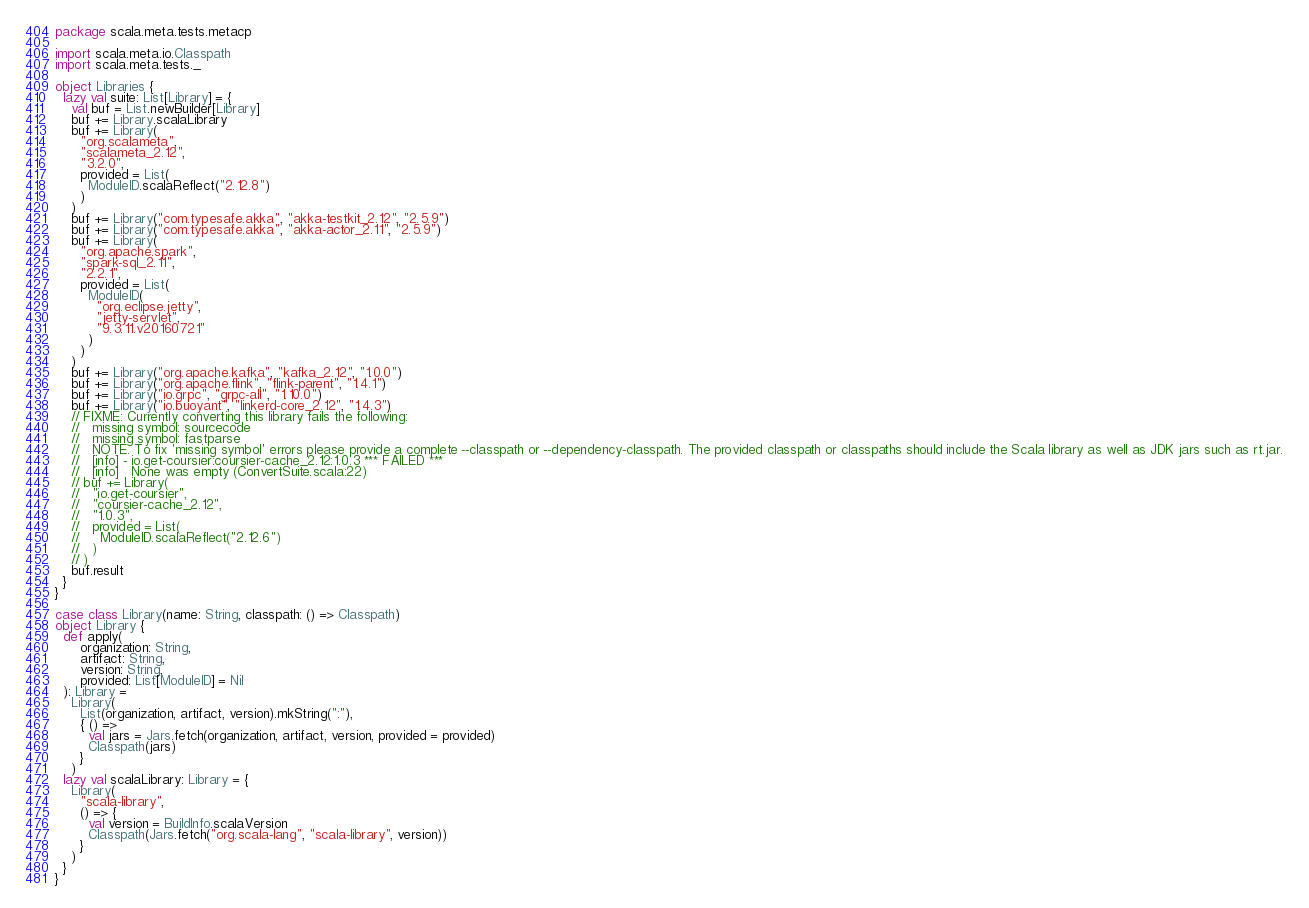<code> <loc_0><loc_0><loc_500><loc_500><_Scala_>package scala.meta.tests.metacp

import scala.meta.io.Classpath
import scala.meta.tests._

object Libraries {
  lazy val suite: List[Library] = {
    val buf = List.newBuilder[Library]
    buf += Library.scalaLibrary
    buf += Library(
      "org.scalameta",
      "scalameta_2.12",
      "3.2.0",
      provided = List(
        ModuleID.scalaReflect("2.12.8")
      )
    )
    buf += Library("com.typesafe.akka", "akka-testkit_2.12", "2.5.9")
    buf += Library("com.typesafe.akka", "akka-actor_2.11", "2.5.9")
    buf += Library(
      "org.apache.spark",
      "spark-sql_2.11",
      "2.2.1",
      provided = List(
        ModuleID(
          "org.eclipse.jetty",
          "jetty-servlet",
          "9.3.11.v20160721"
        )
      )
    )
    buf += Library("org.apache.kafka", "kafka_2.12", "1.0.0")
    buf += Library("org.apache.flink", "flink-parent", "1.4.1")
    buf += Library("io.grpc", "grpc-all", "1.10.0")
    buf += Library("io.buoyant", "linkerd-core_2.12", "1.4.3")
    // FIXME: Currently converting this library fails the following:
    //   missing symbol: sourcecode
    //   missing symbol: fastparse
    //   NOTE. To fix 'missing symbol' errors please provide a complete --classpath or --dependency-classpath. The provided classpath or classpaths should include the Scala library as well as JDK jars such as rt.jar.
    //   [info] - io.get-coursier:coursier-cache_2.12:1.0.3 *** FAILED ***
    //   [info]   None was empty (ConvertSuite.scala:22)
    // buf += Library(
    //   "io.get-coursier",
    //   "coursier-cache_2.12",
    //   "1.0.3",
    //   provided = List(
    //     ModuleID.scalaReflect("2.12.6")
    //   )
    // )
    buf.result
  }
}

case class Library(name: String, classpath: () => Classpath)
object Library {
  def apply(
      organization: String,
      artifact: String,
      version: String,
      provided: List[ModuleID] = Nil
  ): Library =
    Library(
      List(organization, artifact, version).mkString(":"),
      { () =>
        val jars = Jars.fetch(organization, artifact, version, provided = provided)
        Classpath(jars)
      }
    )
  lazy val scalaLibrary: Library = {
    Library(
      "scala-library",
      () => {
        val version = BuildInfo.scalaVersion
        Classpath(Jars.fetch("org.scala-lang", "scala-library", version))
      }
    )
  }
}
</code> 